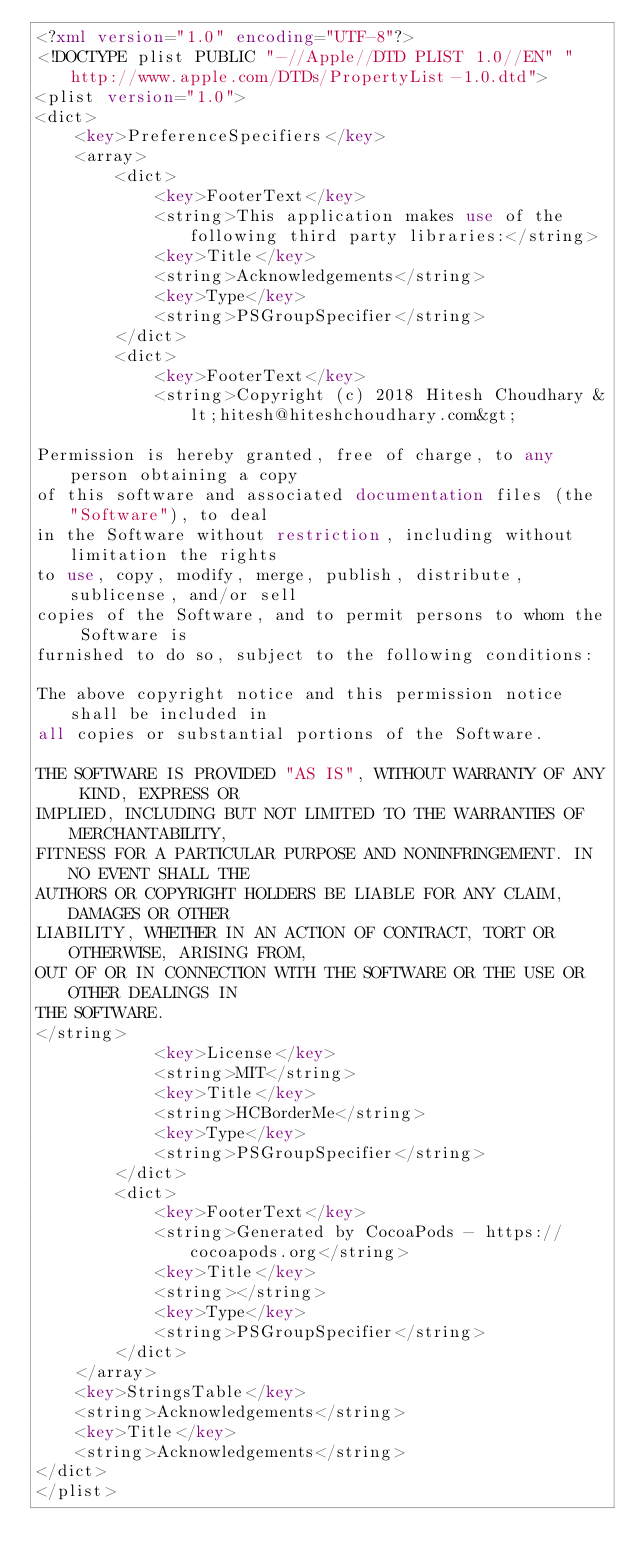<code> <loc_0><loc_0><loc_500><loc_500><_XML_><?xml version="1.0" encoding="UTF-8"?>
<!DOCTYPE plist PUBLIC "-//Apple//DTD PLIST 1.0//EN" "http://www.apple.com/DTDs/PropertyList-1.0.dtd">
<plist version="1.0">
<dict>
	<key>PreferenceSpecifiers</key>
	<array>
		<dict>
			<key>FooterText</key>
			<string>This application makes use of the following third party libraries:</string>
			<key>Title</key>
			<string>Acknowledgements</string>
			<key>Type</key>
			<string>PSGroupSpecifier</string>
		</dict>
		<dict>
			<key>FooterText</key>
			<string>Copyright (c) 2018 Hitesh Choudhary &lt;hitesh@hiteshchoudhary.com&gt;

Permission is hereby granted, free of charge, to any person obtaining a copy
of this software and associated documentation files (the "Software"), to deal
in the Software without restriction, including without limitation the rights
to use, copy, modify, merge, publish, distribute, sublicense, and/or sell
copies of the Software, and to permit persons to whom the Software is
furnished to do so, subject to the following conditions:

The above copyright notice and this permission notice shall be included in
all copies or substantial portions of the Software.

THE SOFTWARE IS PROVIDED "AS IS", WITHOUT WARRANTY OF ANY KIND, EXPRESS OR
IMPLIED, INCLUDING BUT NOT LIMITED TO THE WARRANTIES OF MERCHANTABILITY,
FITNESS FOR A PARTICULAR PURPOSE AND NONINFRINGEMENT. IN NO EVENT SHALL THE
AUTHORS OR COPYRIGHT HOLDERS BE LIABLE FOR ANY CLAIM, DAMAGES OR OTHER
LIABILITY, WHETHER IN AN ACTION OF CONTRACT, TORT OR OTHERWISE, ARISING FROM,
OUT OF OR IN CONNECTION WITH THE SOFTWARE OR THE USE OR OTHER DEALINGS IN
THE SOFTWARE.
</string>
			<key>License</key>
			<string>MIT</string>
			<key>Title</key>
			<string>HCBorderMe</string>
			<key>Type</key>
			<string>PSGroupSpecifier</string>
		</dict>
		<dict>
			<key>FooterText</key>
			<string>Generated by CocoaPods - https://cocoapods.org</string>
			<key>Title</key>
			<string></string>
			<key>Type</key>
			<string>PSGroupSpecifier</string>
		</dict>
	</array>
	<key>StringsTable</key>
	<string>Acknowledgements</string>
	<key>Title</key>
	<string>Acknowledgements</string>
</dict>
</plist>
</code> 